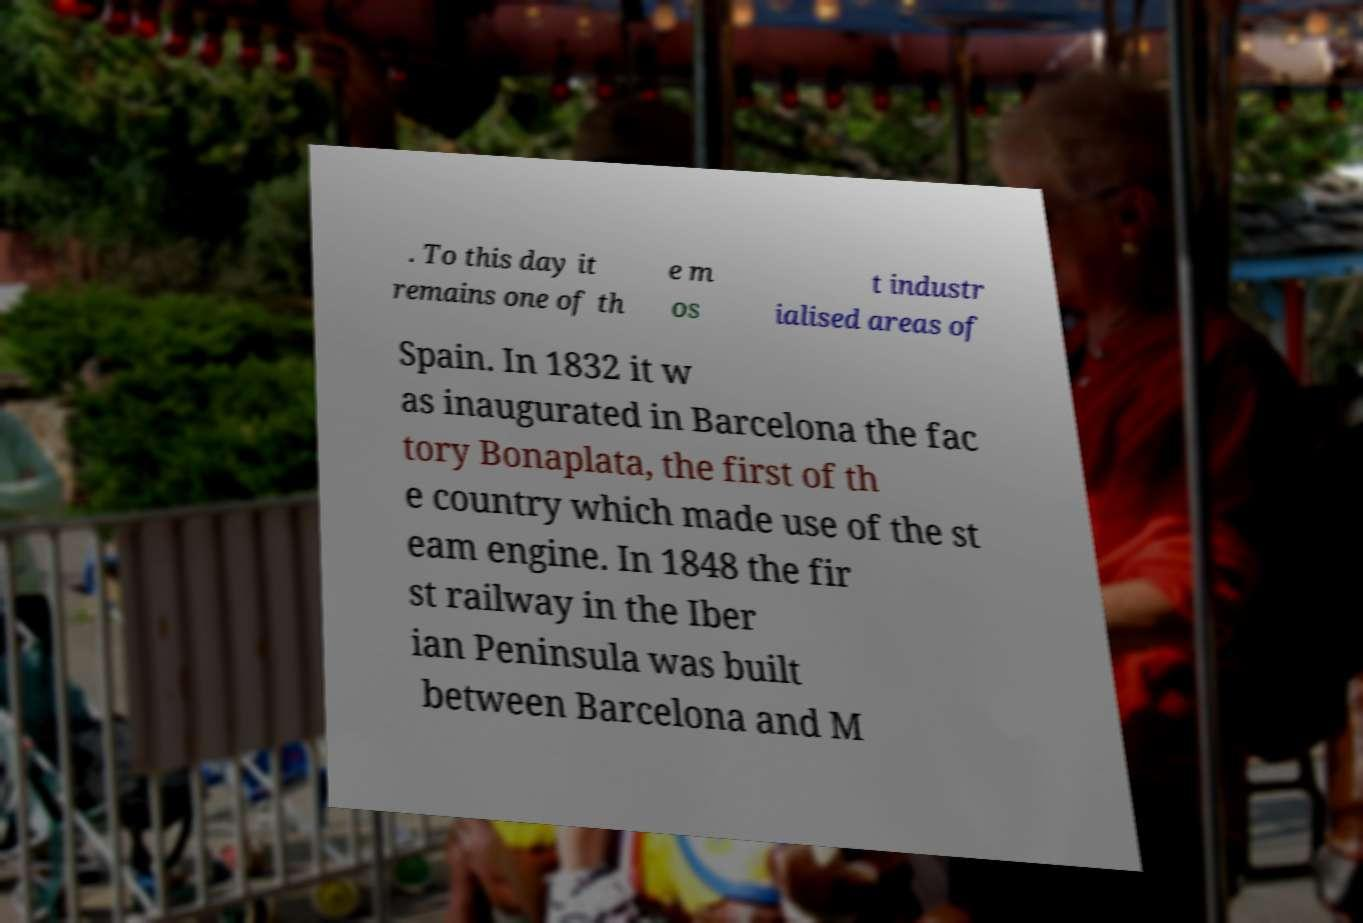Can you accurately transcribe the text from the provided image for me? . To this day it remains one of th e m os t industr ialised areas of Spain. In 1832 it w as inaugurated in Barcelona the fac tory Bonaplata, the first of th e country which made use of the st eam engine. In 1848 the fir st railway in the Iber ian Peninsula was built between Barcelona and M 